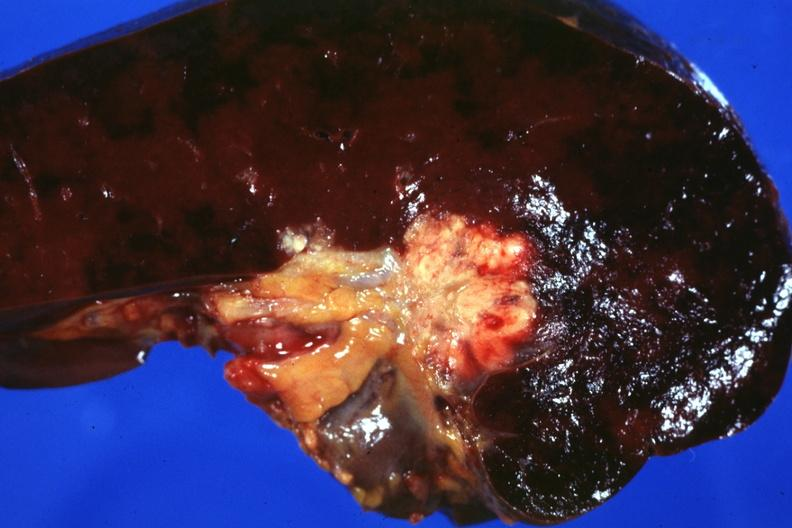s hematologic present?
Answer the question using a single word or phrase. Yes 